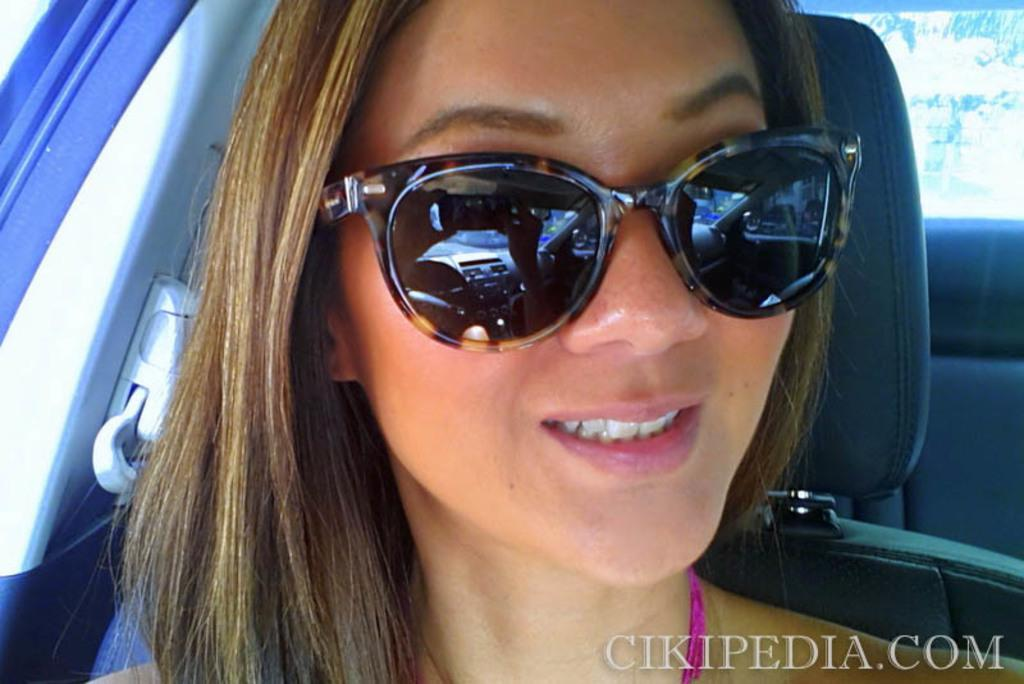What is the main subject of the image? The main subject of the image is a woman's face. What is the woman wearing in the image? The woman is wearing goggles in the image. Where do you think the image was taken? The image appears to be taken inside a vehicle. Is there any additional information or markings on the image? Yes, there is a watermark in the right side bottom of the image. How many trees can be seen in the image? There are no trees visible in the image; it features a woman's face wearing goggles inside a vehicle. What is the size of the woman's skin in the image? The size of the woman's skin cannot be determined from the image, as it only shows her face. 